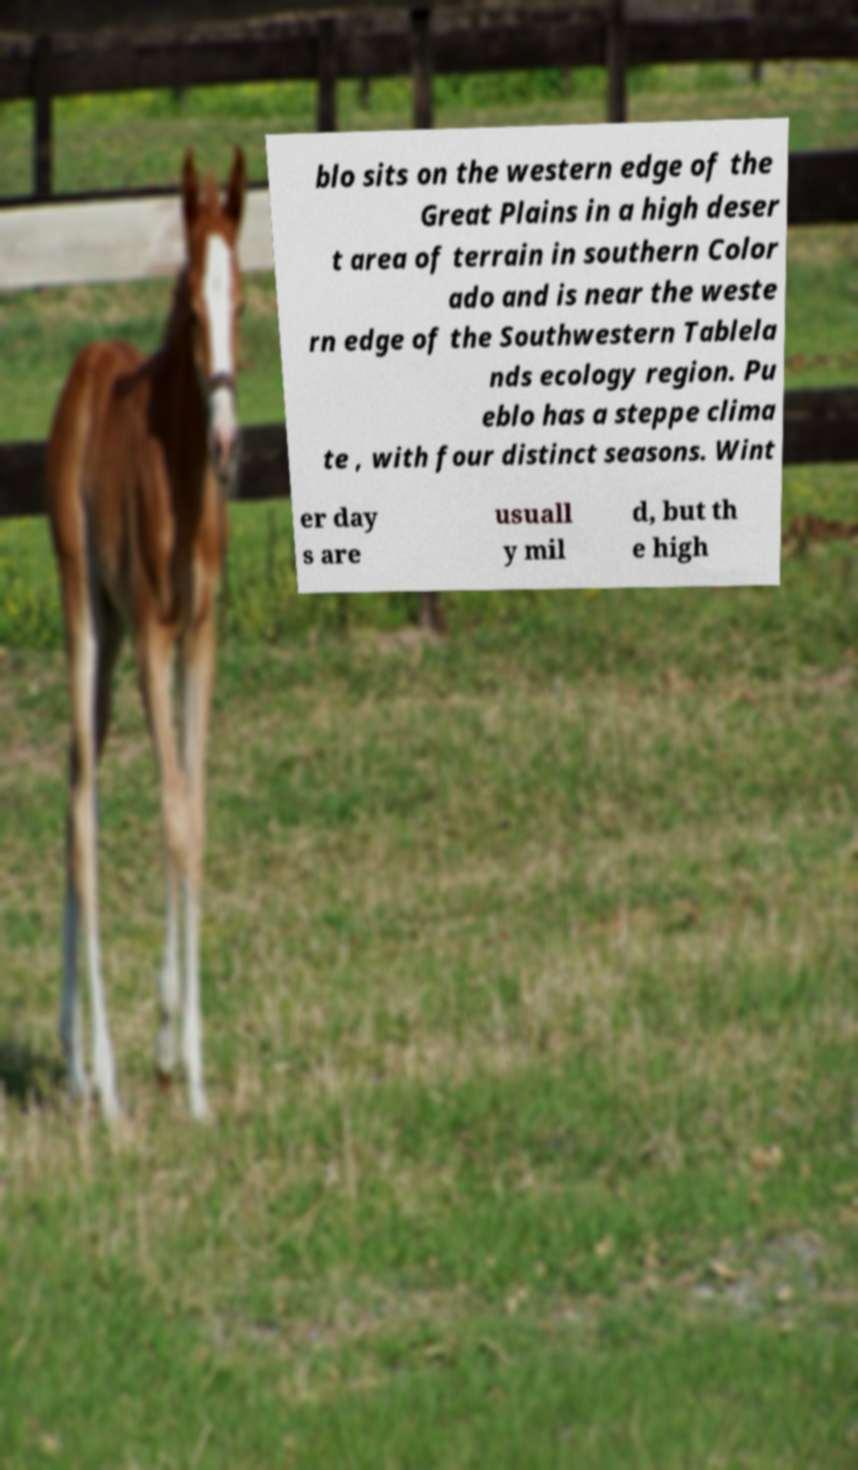I need the written content from this picture converted into text. Can you do that? blo sits on the western edge of the Great Plains in a high deser t area of terrain in southern Color ado and is near the weste rn edge of the Southwestern Tablela nds ecology region. Pu eblo has a steppe clima te , with four distinct seasons. Wint er day s are usuall y mil d, but th e high 